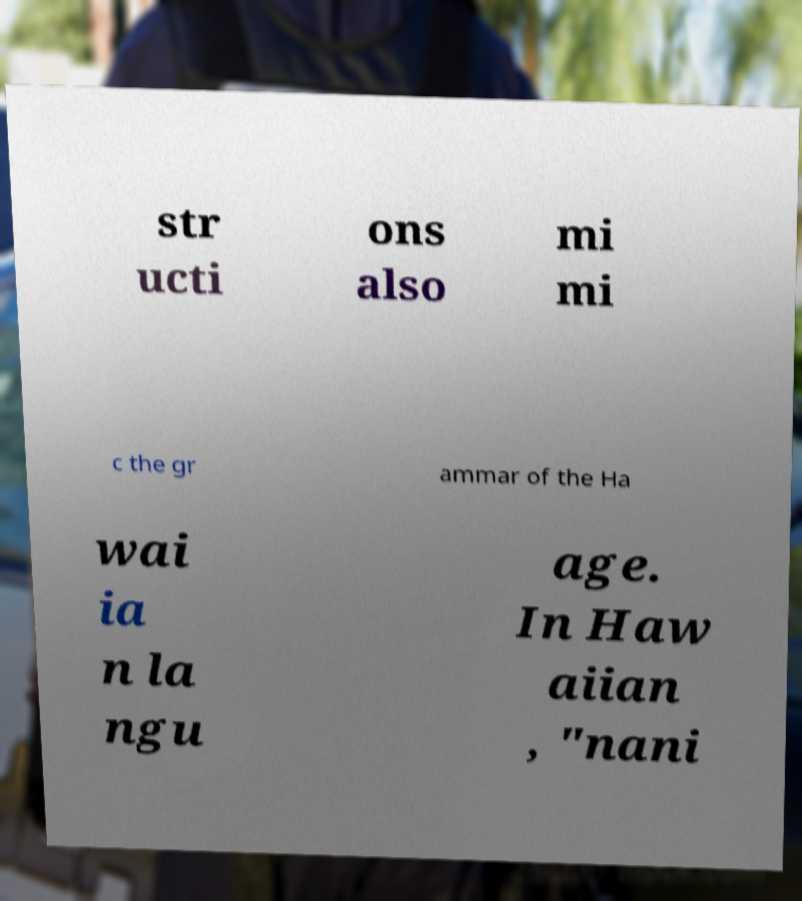There's text embedded in this image that I need extracted. Can you transcribe it verbatim? str ucti ons also mi mi c the gr ammar of the Ha wai ia n la ngu age. In Haw aiian , "nani 